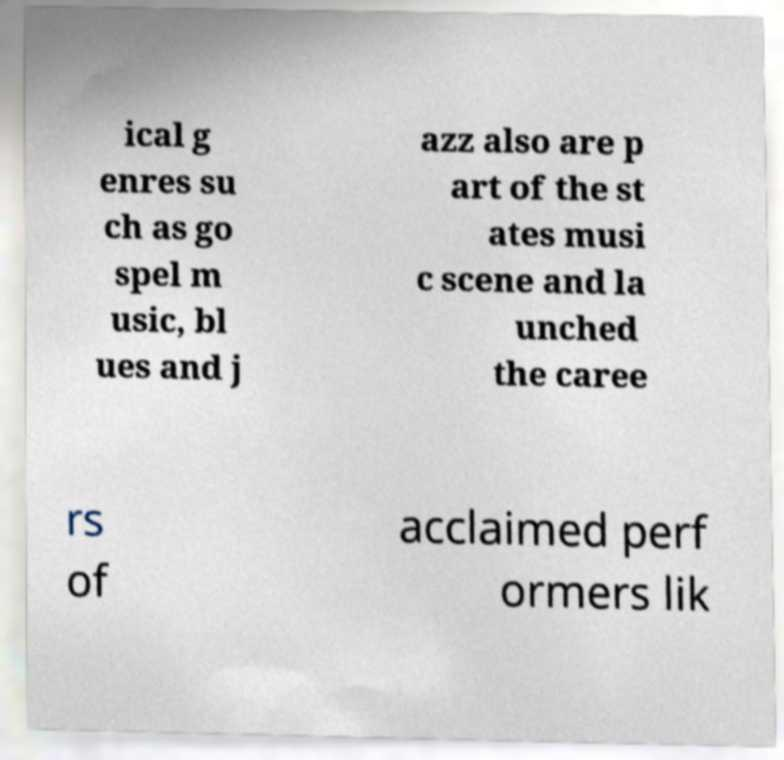For documentation purposes, I need the text within this image transcribed. Could you provide that? ical g enres su ch as go spel m usic, bl ues and j azz also are p art of the st ates musi c scene and la unched the caree rs of acclaimed perf ormers lik 